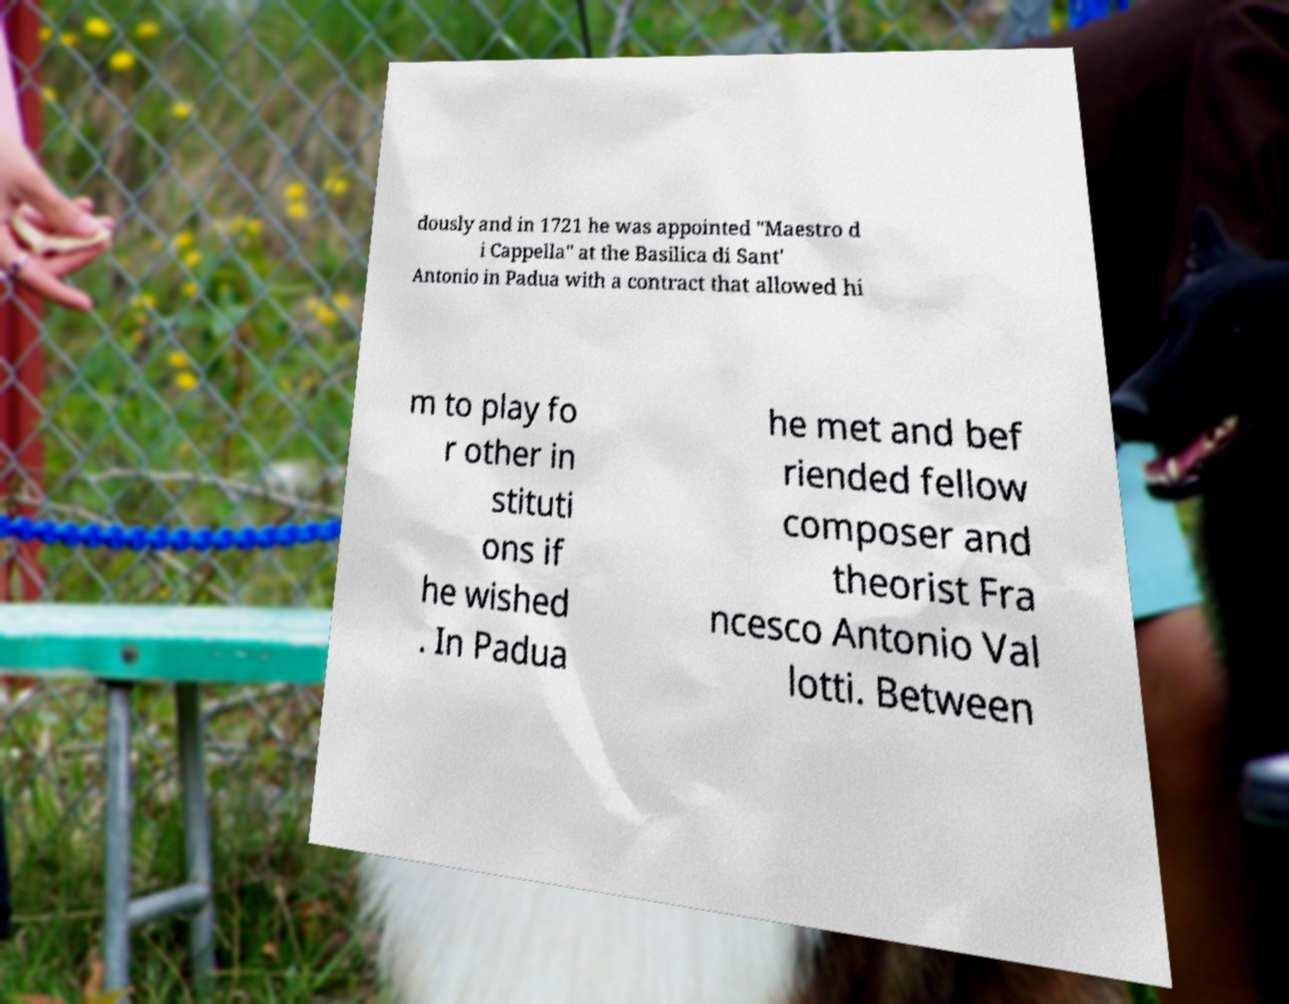Could you assist in decoding the text presented in this image and type it out clearly? dously and in 1721 he was appointed "Maestro d i Cappella" at the Basilica di Sant' Antonio in Padua with a contract that allowed hi m to play fo r other in stituti ons if he wished . In Padua he met and bef riended fellow composer and theorist Fra ncesco Antonio Val lotti. Between 